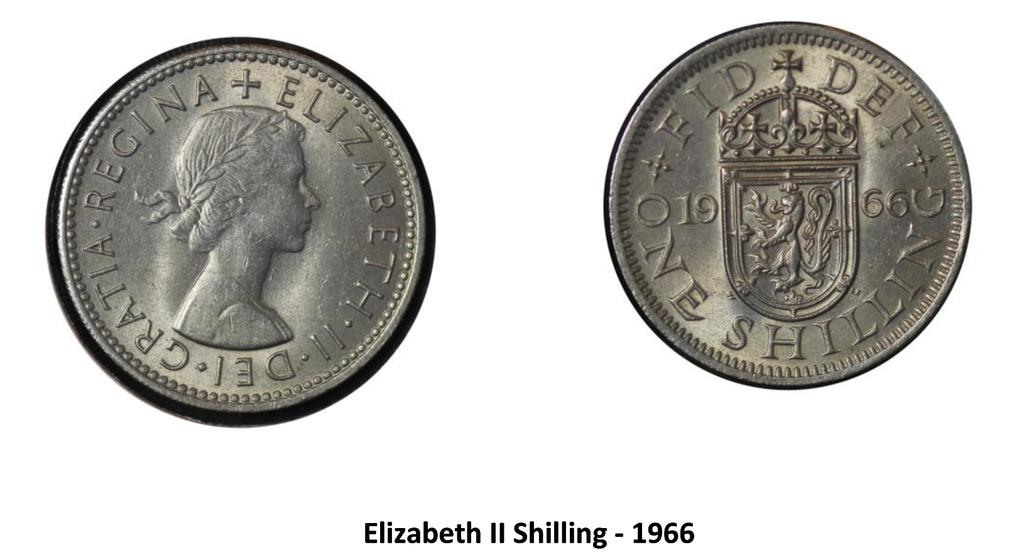<image>
Write a terse but informative summary of the picture. The front and back of an Eliabeth II Shilling are shown. 